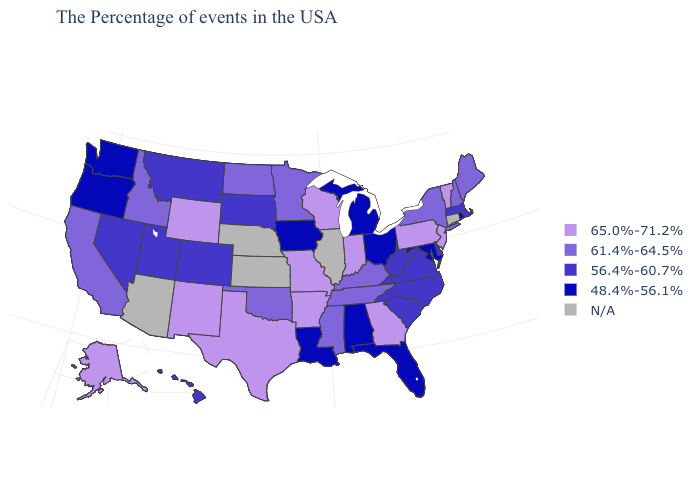Among the states that border Florida , which have the highest value?
Short answer required. Georgia. Is the legend a continuous bar?
Short answer required. No. Name the states that have a value in the range N/A?
Write a very short answer. Connecticut, Illinois, Kansas, Nebraska, Arizona. Name the states that have a value in the range 65.0%-71.2%?
Concise answer only. Vermont, New Jersey, Pennsylvania, Georgia, Indiana, Wisconsin, Missouri, Arkansas, Texas, Wyoming, New Mexico, Alaska. Does the first symbol in the legend represent the smallest category?
Be succinct. No. Name the states that have a value in the range 65.0%-71.2%?
Give a very brief answer. Vermont, New Jersey, Pennsylvania, Georgia, Indiana, Wisconsin, Missouri, Arkansas, Texas, Wyoming, New Mexico, Alaska. Which states have the lowest value in the Northeast?
Answer briefly. Rhode Island. Name the states that have a value in the range N/A?
Give a very brief answer. Connecticut, Illinois, Kansas, Nebraska, Arizona. What is the value of New Jersey?
Be succinct. 65.0%-71.2%. What is the value of Washington?
Be succinct. 48.4%-56.1%. What is the value of Mississippi?
Be succinct. 61.4%-64.5%. Name the states that have a value in the range 56.4%-60.7%?
Be succinct. Massachusetts, Delaware, Virginia, North Carolina, South Carolina, West Virginia, South Dakota, Colorado, Utah, Montana, Nevada, Hawaii. 